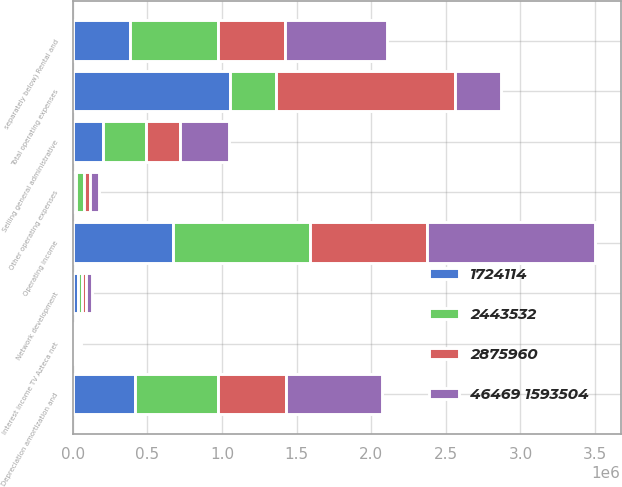Convert chart to OTSL. <chart><loc_0><loc_0><loc_500><loc_500><stacked_bar_chart><ecel><fcel>separately below) Rental and<fcel>Network development<fcel>Depreciation amortization and<fcel>Selling general administrative<fcel>Other operating expenses<fcel>Total operating expenses<fcel>Operating income<fcel>Interest income TV Azteca net<nl><fcel>46469 1593504<fcel>686681<fcel>35798<fcel>644276<fcel>327301<fcel>62185<fcel>308062<fcel>1.11972e+06<fcel>14258<nl><fcel>2443532<fcel>590272<fcel>30684<fcel>555517<fcel>288824<fcel>58103<fcel>308062<fcel>920132<fcel>14214<nl><fcel>2875960<fcel>447629<fcel>26957<fcel>460726<fcel>229769<fcel>35876<fcel>1.20096e+06<fcel>784378<fcel>14212<nl><fcel>1724114<fcel>383990<fcel>32385<fcel>414619<fcel>201694<fcel>19168<fcel>1.05186e+06<fcel>672258<fcel>14210<nl></chart> 